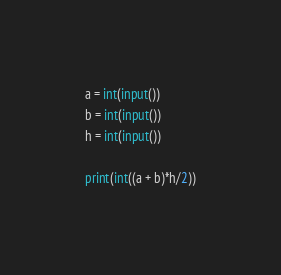<code> <loc_0><loc_0><loc_500><loc_500><_Python_>
a = int(input())
b = int(input())
h = int(input())

print(int((a + b)*h/2))</code> 